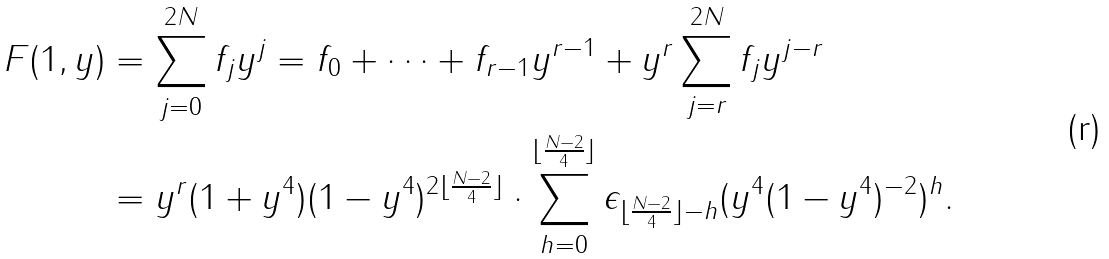Convert formula to latex. <formula><loc_0><loc_0><loc_500><loc_500>F ( 1 , y ) & = \sum _ { j = 0 } ^ { 2 N } f _ { j } y ^ { j } = f _ { 0 } + \dots + f _ { r - 1 } y ^ { r - 1 } + y ^ { r } \sum _ { j = r } ^ { 2 N } f _ { j } y ^ { j - r } \\ & = y ^ { r } ( 1 + y ^ { 4 } ) ( 1 - y ^ { 4 } ) ^ { 2 \lfloor \frac { N - 2 } { 4 } \rfloor } \cdot \sum _ { h = 0 } ^ { \lfloor \frac { N - 2 } { 4 } \rfloor } \epsilon _ { \lfloor \frac { N - 2 } { 4 } \rfloor - h } ( y ^ { 4 } ( 1 - y ^ { 4 } ) ^ { - 2 } ) ^ { h } .</formula> 